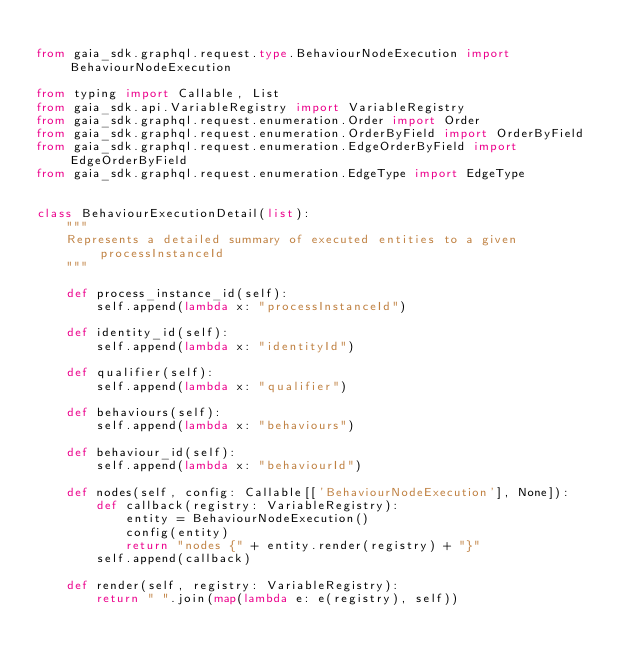Convert code to text. <code><loc_0><loc_0><loc_500><loc_500><_Python_>
from gaia_sdk.graphql.request.type.BehaviourNodeExecution import BehaviourNodeExecution

from typing import Callable, List
from gaia_sdk.api.VariableRegistry import VariableRegistry
from gaia_sdk.graphql.request.enumeration.Order import Order
from gaia_sdk.graphql.request.enumeration.OrderByField import OrderByField
from gaia_sdk.graphql.request.enumeration.EdgeOrderByField import EdgeOrderByField
from gaia_sdk.graphql.request.enumeration.EdgeType import EdgeType


class BehaviourExecutionDetail(list):
    """
    Represents a detailed summary of executed entities to a given processInstanceId
    """

    def process_instance_id(self):
        self.append(lambda x: "processInstanceId")

    def identity_id(self):
        self.append(lambda x: "identityId")

    def qualifier(self):
        self.append(lambda x: "qualifier")

    def behaviours(self):
        self.append(lambda x: "behaviours")

    def behaviour_id(self):
        self.append(lambda x: "behaviourId")

    def nodes(self, config: Callable[['BehaviourNodeExecution'], None]):
        def callback(registry: VariableRegistry):
            entity = BehaviourNodeExecution()
            config(entity)
            return "nodes {" + entity.render(registry) + "}"
        self.append(callback)

    def render(self, registry: VariableRegistry):
        return " ".join(map(lambda e: e(registry), self))
</code> 